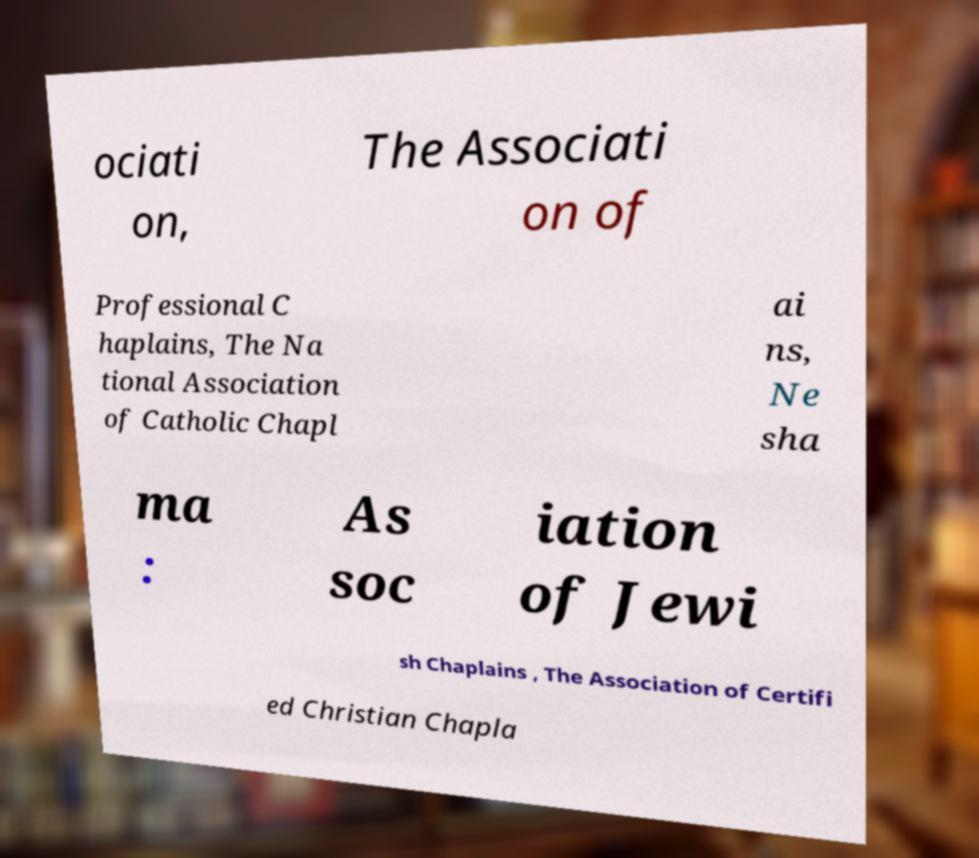Could you extract and type out the text from this image? ociati on, The Associati on of Professional C haplains, The Na tional Association of Catholic Chapl ai ns, Ne sha ma : As soc iation of Jewi sh Chaplains , The Association of Certifi ed Christian Chapla 